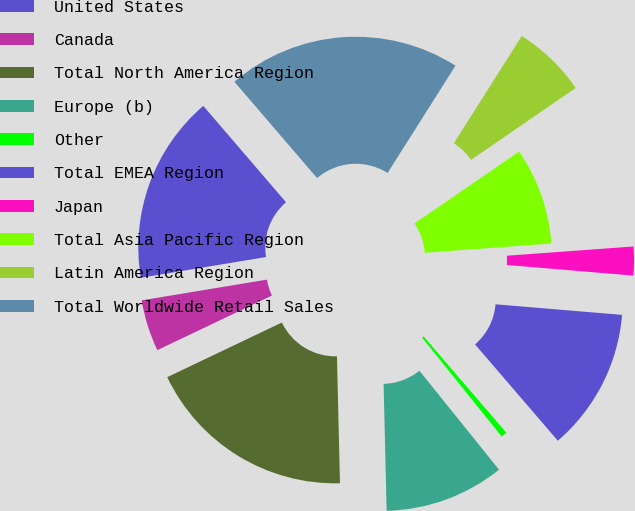<chart> <loc_0><loc_0><loc_500><loc_500><pie_chart><fcel>United States<fcel>Canada<fcel>Total North America Region<fcel>Europe (b)<fcel>Other<fcel>Total EMEA Region<fcel>Japan<fcel>Total Asia Pacific Region<fcel>Latin America Region<fcel>Total Worldwide Retail Sales<nl><fcel>16.32%<fcel>4.47%<fcel>18.3%<fcel>10.4%<fcel>0.52%<fcel>12.37%<fcel>2.49%<fcel>8.42%<fcel>6.44%<fcel>20.27%<nl></chart> 